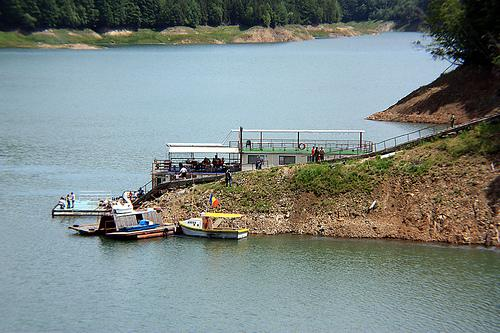People standing on something solid furthest into and above water stand on what? Please explain your reasoning. pier. A pier juts out into the water and allows people to get on a boat if they wish to. 